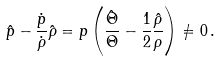Convert formula to latex. <formula><loc_0><loc_0><loc_500><loc_500>\hat { p } - \frac { \dot { p } } { \dot { \rho } } \hat { \rho } = p \left ( \frac { \hat { \Theta } } { \Theta } - \frac { 1 } { 2 } \frac { \hat { \rho } } { \rho } \right ) \neq 0 \, .</formula> 